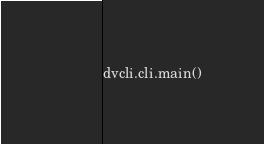<code> <loc_0><loc_0><loc_500><loc_500><_Python_>dvcli.cli.main()
</code> 